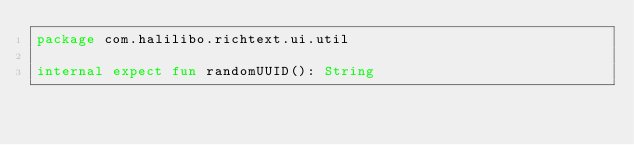<code> <loc_0><loc_0><loc_500><loc_500><_Kotlin_>package com.halilibo.richtext.ui.util

internal expect fun randomUUID(): String</code> 